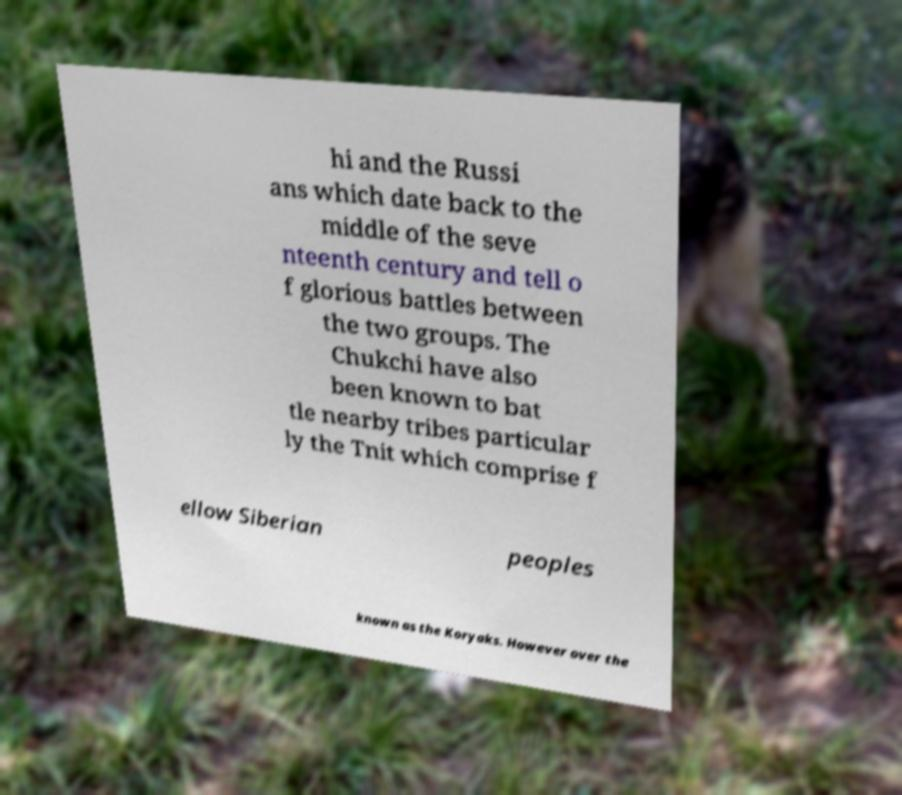Could you extract and type out the text from this image? hi and the Russi ans which date back to the middle of the seve nteenth century and tell o f glorious battles between the two groups. The Chukchi have also been known to bat tle nearby tribes particular ly the Tnit which comprise f ellow Siberian peoples known as the Koryaks. However over the 